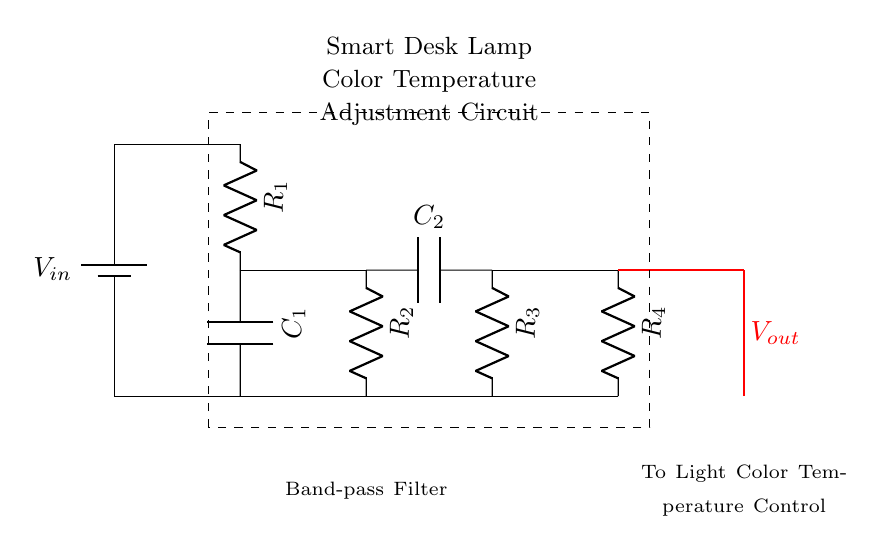What is the component labeled R1? R1 is a resistor, indicated by the label attached to the symbol used in the circuit diagram. Resistors are typically represented in diagrams by a zigzag line.
Answer: Resistor What is the total voltage supplied to this circuit? The circuit is connected to a battery, marked as V_in. The specific value isn’t provided in the diagram, so we identify it as V_in without a numeric value.
Answer: V_in How many capacitors are present in this circuit? There are two capacitors shown in the circuit, labeled as C1 and C2. Both are essential components in a band-pass filter, allowing specific frequency signals to pass.
Answer: 2 What type of filter is represented in this circuit? The circuit structure, with both resistors and capacitors, indicates it is a band-pass filter. This filter allows frequencies within a certain range to pass while attenuating frequencies outside that range.
Answer: Band-pass filter What is the purpose of this circuit labeled at the bottom? The label under the circuit diagram indicates that it is intended for light color temperature adjustment. This suggests the circuit is designed to enable a smart desk lamp to adapt its light output based on the time of day.
Answer: Light color temperature adjustment 